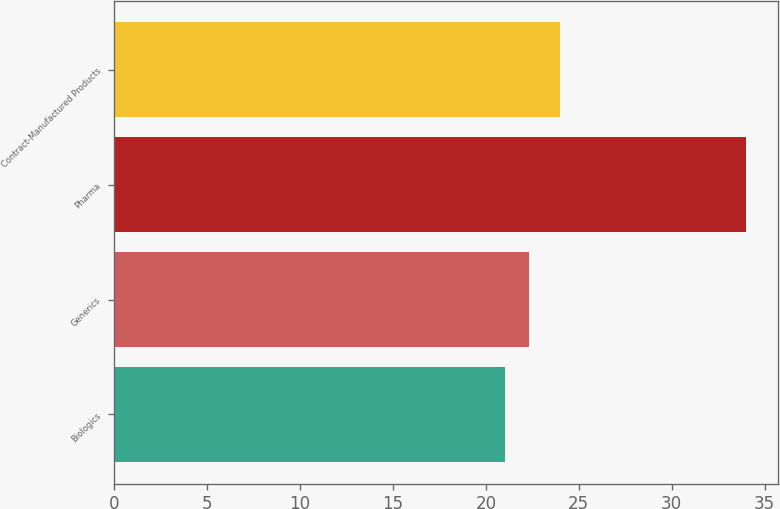Convert chart. <chart><loc_0><loc_0><loc_500><loc_500><bar_chart><fcel>Biologics<fcel>Generics<fcel>Pharma<fcel>Contract-Manufactured Products<nl><fcel>21<fcel>22.3<fcel>34<fcel>24<nl></chart> 